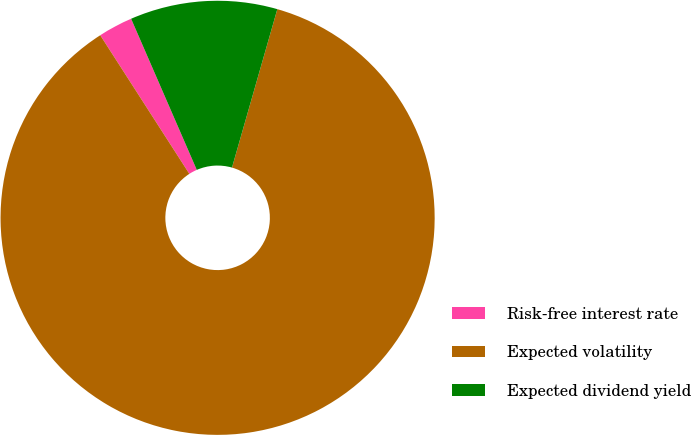<chart> <loc_0><loc_0><loc_500><loc_500><pie_chart><fcel>Risk-free interest rate<fcel>Expected volatility<fcel>Expected dividend yield<nl><fcel>2.57%<fcel>86.47%<fcel>10.96%<nl></chart> 